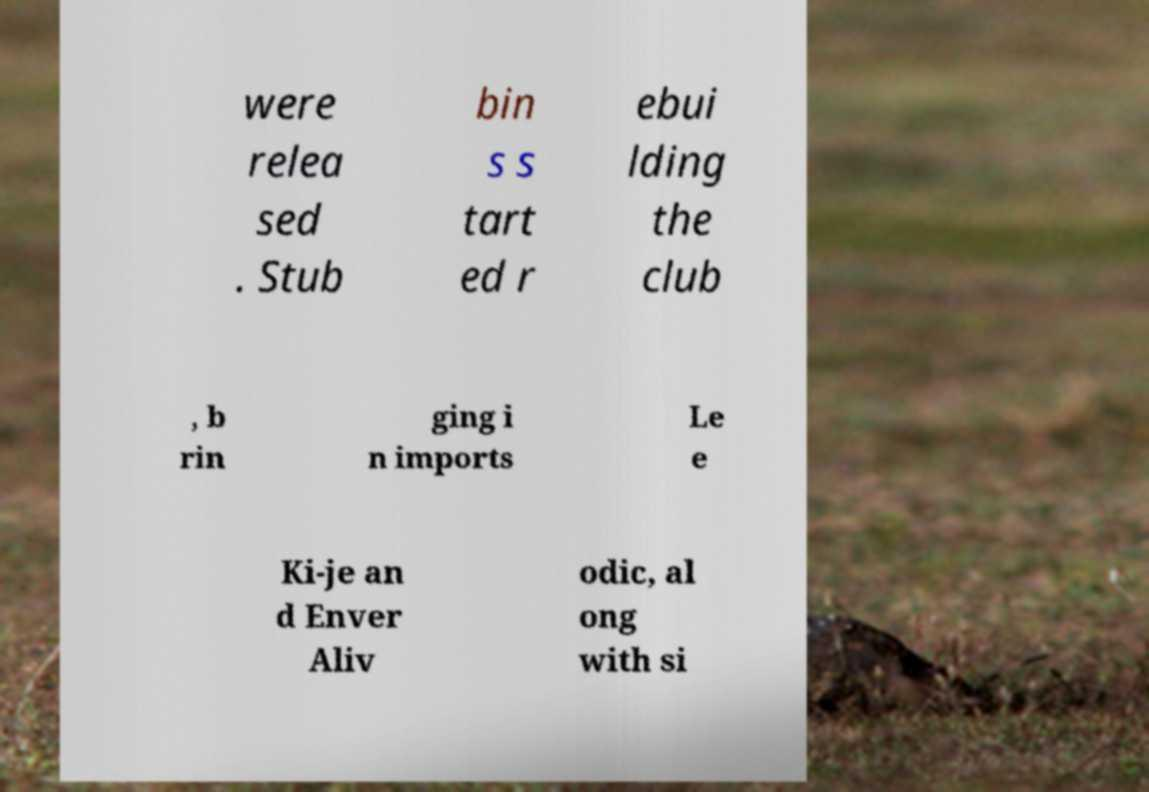Could you assist in decoding the text presented in this image and type it out clearly? were relea sed . Stub bin s s tart ed r ebui lding the club , b rin ging i n imports Le e Ki-je an d Enver Aliv odic, al ong with si 